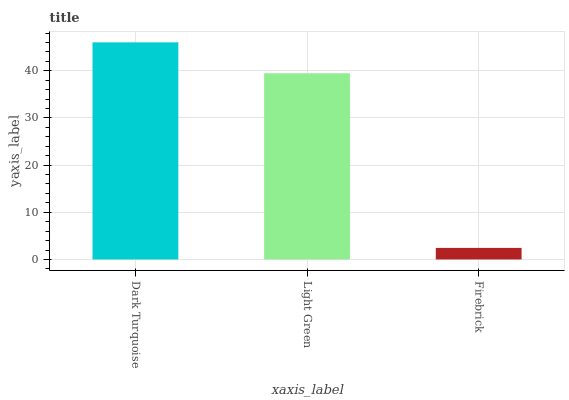Is Light Green the minimum?
Answer yes or no. No. Is Light Green the maximum?
Answer yes or no. No. Is Dark Turquoise greater than Light Green?
Answer yes or no. Yes. Is Light Green less than Dark Turquoise?
Answer yes or no. Yes. Is Light Green greater than Dark Turquoise?
Answer yes or no. No. Is Dark Turquoise less than Light Green?
Answer yes or no. No. Is Light Green the high median?
Answer yes or no. Yes. Is Light Green the low median?
Answer yes or no. Yes. Is Firebrick the high median?
Answer yes or no. No. Is Firebrick the low median?
Answer yes or no. No. 